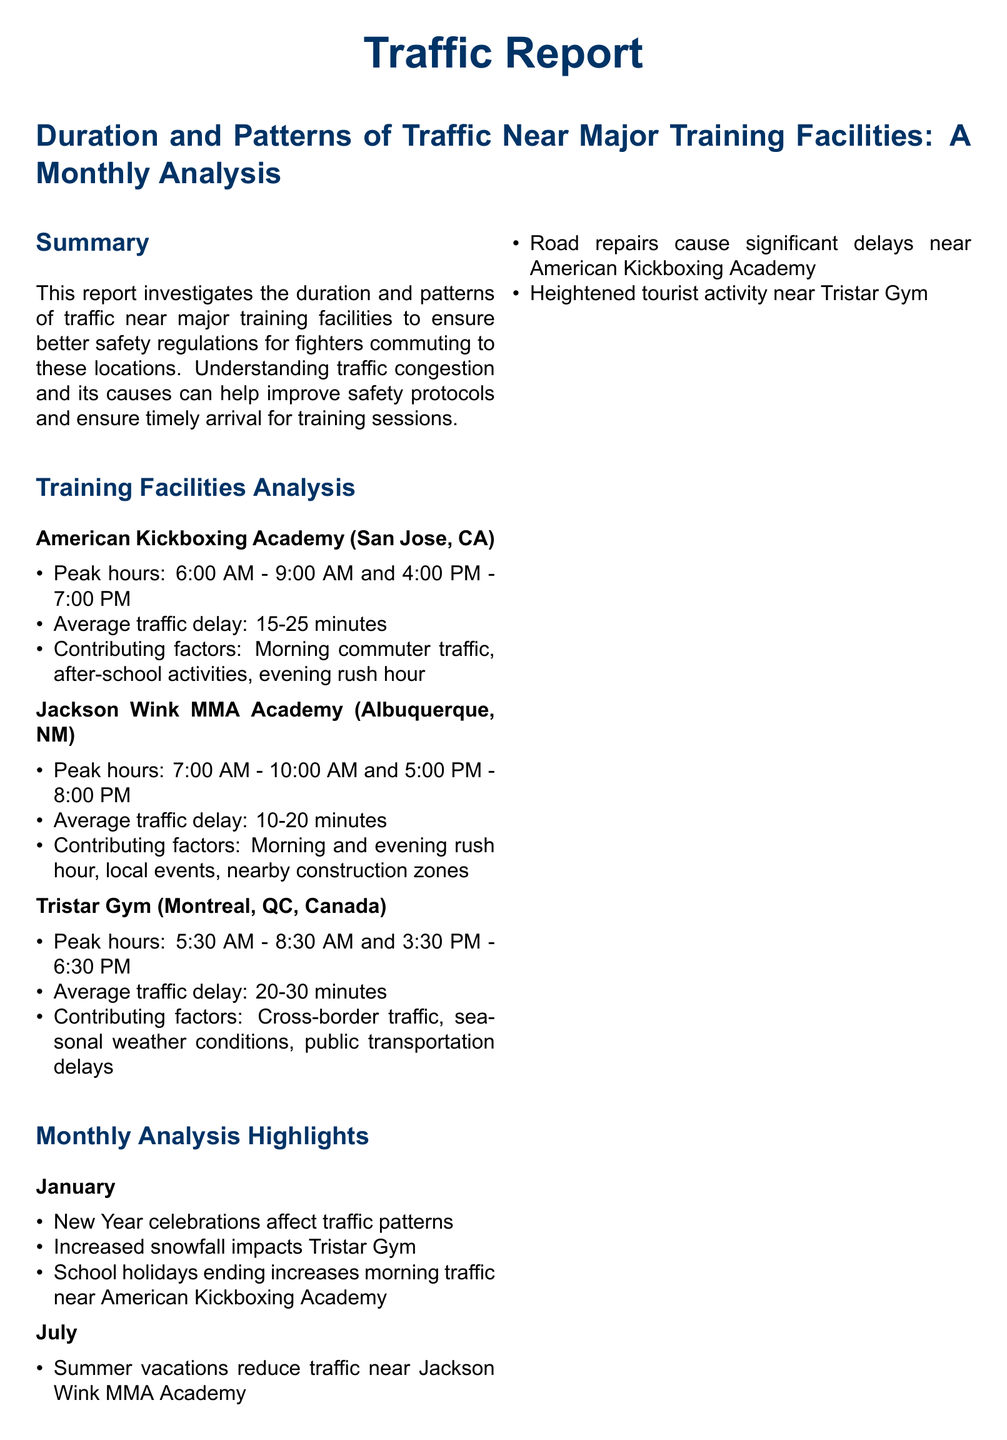What are the peak hours for American Kickboxing Academy? The peak hours for American Kickboxing Academy are stated in the document as 6:00 AM - 9:00 AM and 4:00 PM - 7:00 PM.
Answer: 6:00 AM - 9:00 AM and 4:00 PM - 7:00 PM What is the average traffic delay at Jackson Wink MMA Academy? The average traffic delay for Jackson Wink MMA Academy is mentioned to be between 10-20 minutes.
Answer: 10-20 minutes Which factors contribute to traffic delays at Tristar Gym? The contributing factors for traffic delays at Tristar Gym include cross-border traffic, seasonal weather conditions, and public transportation delays.
Answer: Cross-border traffic, seasonal weather conditions, public transportation delays What month shows increased snowfall impacting Tristar Gym? The document notes that increased snowfall impacts Tristar Gym during January.
Answer: January How are training schedules recommended to be adjusted? The recommendation states that training schedules should be modified to avoid peak traffic hours when feasible.
Answer: Avoid peak traffic hours What is one reason for increased morning traffic near American Kickboxing Academy in January? The document specifies that school holidays ending increases morning traffic near American Kickboxing Academy in January.
Answer: School holidays ending What is a suggested alternative to reduce traffic congestion? The document suggests utilizing real-time traffic apps like Waze to identify less congested routes.
Answer: Real-time traffic apps like Waze 